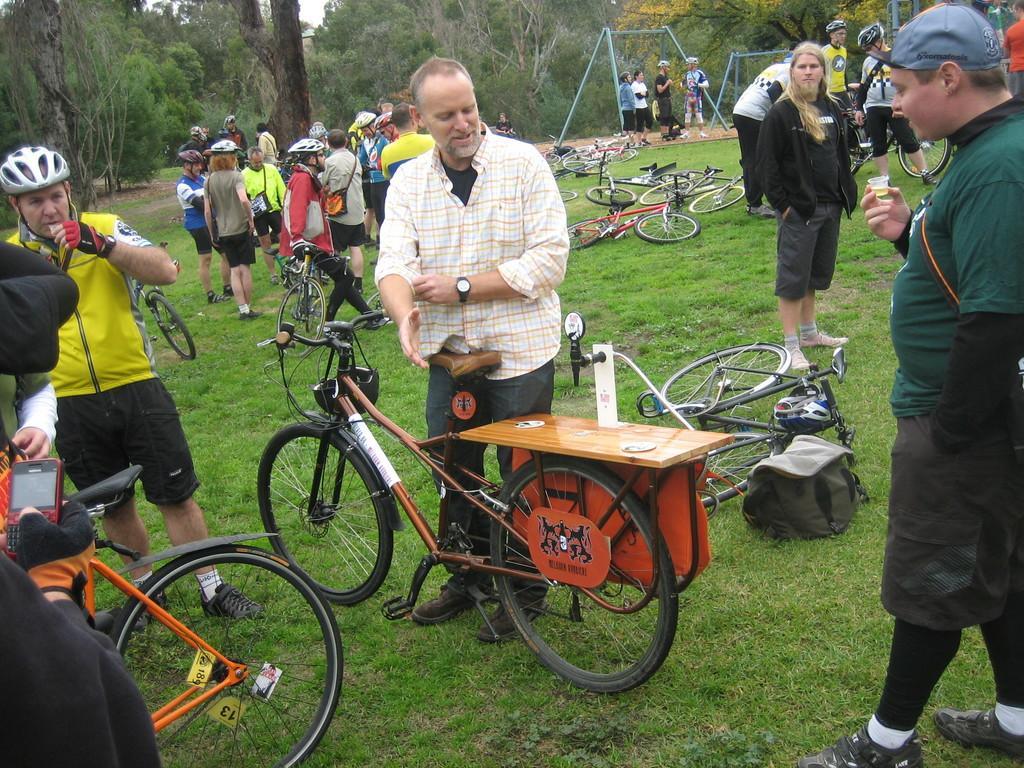Describe this image in one or two sentences. In this image we can see so many people and bicycle on the grassy land. At the top of the image trees are there. 